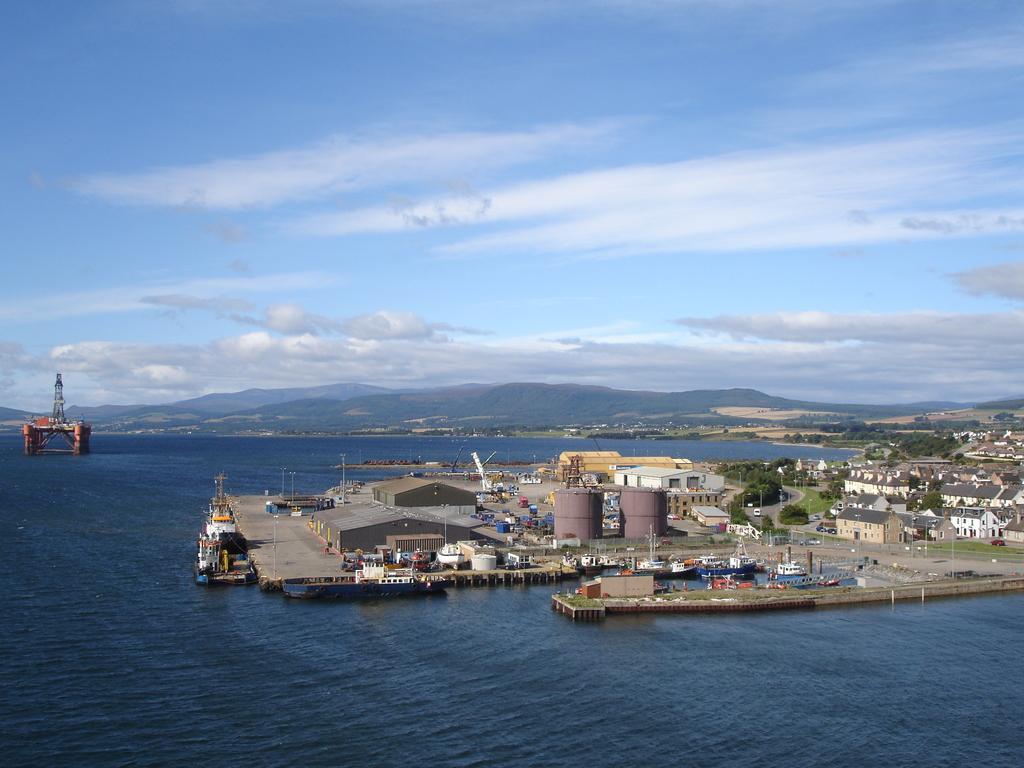Can you describe this image briefly? In this image we can see some buildings, sheds, tanks, we can see a ship, there is an object in the ocean, also we can see the sky, mountains, trees. 